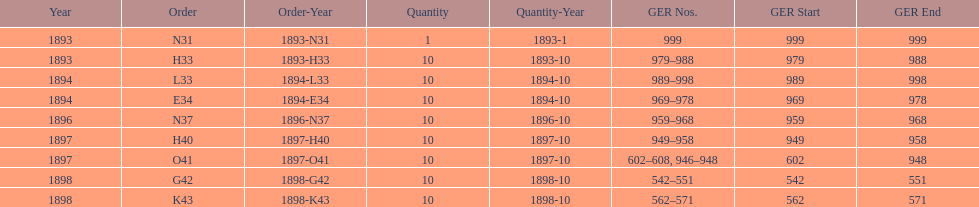Would you mind parsing the complete table? {'header': ['Year', 'Order', 'Order-Year', 'Quantity', 'Quantity-Year', 'GER Nos.', 'GER Start', 'GER End'], 'rows': [['1893', 'N31', '1893-N31', '1', '1893-1', '999', '999', '999'], ['1893', 'H33', '1893-H33', '10', '1893-10', '979–988', '979', '988'], ['1894', 'L33', '1894-L33', '10', '1894-10', '989–998', '989', '998'], ['1894', 'E34', '1894-E34', '10', '1894-10', '969–978', '969', '978'], ['1896', 'N37', '1896-N37', '10', '1896-10', '959–968', '959', '968'], ['1897', 'H40', '1897-H40', '10', '1897-10', '949–958', '949', '958'], ['1897', 'O41', '1897-O41', '10', '1897-10', '602–608, 946–948', '602', '948'], ['1898', 'G42', '1898-G42', '10', '1898-10', '542–551', '542', '551'], ['1898', 'K43', '1898-K43', '10', '1898-10', '562–571', '562', '571']]} What is the order of the last year listed? K43. 